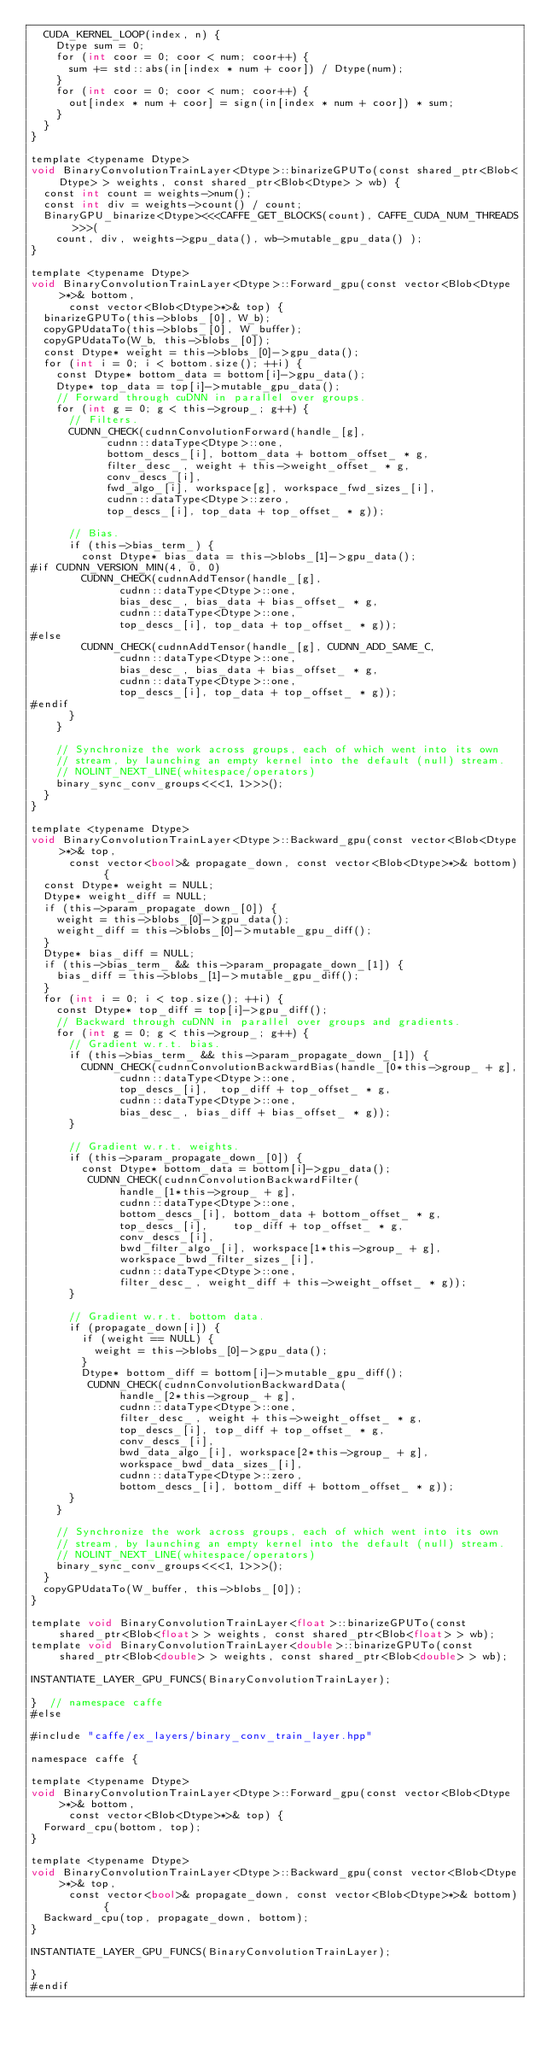Convert code to text. <code><loc_0><loc_0><loc_500><loc_500><_Cuda_>  CUDA_KERNEL_LOOP(index, n) {
    Dtype sum = 0;
    for (int coor = 0; coor < num; coor++) {
      sum += std::abs(in[index * num + coor]) / Dtype(num);
    }
    for (int coor = 0; coor < num; coor++) {
      out[index * num + coor] = sign(in[index * num + coor]) * sum;
    }
  }  
}

template <typename Dtype>
void BinaryConvolutionTrainLayer<Dtype>::binarizeGPUTo(const shared_ptr<Blob<Dtype> > weights, const shared_ptr<Blob<Dtype> > wb) {
  const int count = weights->num();
  const int div = weights->count() / count;
  BinaryGPU_binarize<Dtype><<<CAFFE_GET_BLOCKS(count), CAFFE_CUDA_NUM_THREADS>>>(
    count, div, weights->gpu_data(), wb->mutable_gpu_data() );
}

template <typename Dtype>
void BinaryConvolutionTrainLayer<Dtype>::Forward_gpu(const vector<Blob<Dtype>*>& bottom,
      const vector<Blob<Dtype>*>& top) {
  binarizeGPUTo(this->blobs_[0], W_b);
  copyGPUdataTo(this->blobs_[0], W_buffer);
  copyGPUdataTo(W_b, this->blobs_[0]);
  const Dtype* weight = this->blobs_[0]->gpu_data();
  for (int i = 0; i < bottom.size(); ++i) {
    const Dtype* bottom_data = bottom[i]->gpu_data();
    Dtype* top_data = top[i]->mutable_gpu_data();
    // Forward through cuDNN in parallel over groups.
    for (int g = 0; g < this->group_; g++) {
      // Filters.
      CUDNN_CHECK(cudnnConvolutionForward(handle_[g],
            cudnn::dataType<Dtype>::one,
            bottom_descs_[i], bottom_data + bottom_offset_ * g,
            filter_desc_, weight + this->weight_offset_ * g,
            conv_descs_[i],
            fwd_algo_[i], workspace[g], workspace_fwd_sizes_[i],
            cudnn::dataType<Dtype>::zero,
            top_descs_[i], top_data + top_offset_ * g));

      // Bias.
      if (this->bias_term_) {
        const Dtype* bias_data = this->blobs_[1]->gpu_data();
#if CUDNN_VERSION_MIN(4, 0, 0)
        CUDNN_CHECK(cudnnAddTensor(handle_[g],
              cudnn::dataType<Dtype>::one,
              bias_desc_, bias_data + bias_offset_ * g,
              cudnn::dataType<Dtype>::one,
              top_descs_[i], top_data + top_offset_ * g));
#else
        CUDNN_CHECK(cudnnAddTensor(handle_[g], CUDNN_ADD_SAME_C,
              cudnn::dataType<Dtype>::one,
              bias_desc_, bias_data + bias_offset_ * g,
              cudnn::dataType<Dtype>::one,
              top_descs_[i], top_data + top_offset_ * g));
#endif
      }
    }

    // Synchronize the work across groups, each of which went into its own
    // stream, by launching an empty kernel into the default (null) stream.
    // NOLINT_NEXT_LINE(whitespace/operators)
    binary_sync_conv_groups<<<1, 1>>>();
  }
}

template <typename Dtype>
void BinaryConvolutionTrainLayer<Dtype>::Backward_gpu(const vector<Blob<Dtype>*>& top,
      const vector<bool>& propagate_down, const vector<Blob<Dtype>*>& bottom) {
  const Dtype* weight = NULL;
  Dtype* weight_diff = NULL;
  if (this->param_propagate_down_[0]) {
    weight = this->blobs_[0]->gpu_data();
    weight_diff = this->blobs_[0]->mutable_gpu_diff();
  }
  Dtype* bias_diff = NULL;
  if (this->bias_term_ && this->param_propagate_down_[1]) {
    bias_diff = this->blobs_[1]->mutable_gpu_diff();
  }
  for (int i = 0; i < top.size(); ++i) {
    const Dtype* top_diff = top[i]->gpu_diff();
    // Backward through cuDNN in parallel over groups and gradients.
    for (int g = 0; g < this->group_; g++) {
      // Gradient w.r.t. bias.
      if (this->bias_term_ && this->param_propagate_down_[1]) {
        CUDNN_CHECK(cudnnConvolutionBackwardBias(handle_[0*this->group_ + g],
              cudnn::dataType<Dtype>::one,
              top_descs_[i],  top_diff + top_offset_ * g,
              cudnn::dataType<Dtype>::one,
              bias_desc_, bias_diff + bias_offset_ * g));
      }

      // Gradient w.r.t. weights.
      if (this->param_propagate_down_[0]) {
        const Dtype* bottom_data = bottom[i]->gpu_data();
         CUDNN_CHECK(cudnnConvolutionBackwardFilter(
              handle_[1*this->group_ + g],
              cudnn::dataType<Dtype>::one,
              bottom_descs_[i], bottom_data + bottom_offset_ * g,
              top_descs_[i],    top_diff + top_offset_ * g,
              conv_descs_[i],
              bwd_filter_algo_[i], workspace[1*this->group_ + g],
              workspace_bwd_filter_sizes_[i],
              cudnn::dataType<Dtype>::one,
              filter_desc_, weight_diff + this->weight_offset_ * g)); 
      }

      // Gradient w.r.t. bottom data.
      if (propagate_down[i]) {
        if (weight == NULL) {
          weight = this->blobs_[0]->gpu_data();
        }
        Dtype* bottom_diff = bottom[i]->mutable_gpu_diff();
         CUDNN_CHECK(cudnnConvolutionBackwardData(
              handle_[2*this->group_ + g],
              cudnn::dataType<Dtype>::one,
              filter_desc_, weight + this->weight_offset_ * g,
              top_descs_[i], top_diff + top_offset_ * g,
              conv_descs_[i],
              bwd_data_algo_[i], workspace[2*this->group_ + g],
              workspace_bwd_data_sizes_[i],
              cudnn::dataType<Dtype>::zero,
              bottom_descs_[i], bottom_diff + bottom_offset_ * g));
      }
    }

    // Synchronize the work across groups, each of which went into its own
    // stream, by launching an empty kernel into the default (null) stream.
    // NOLINT_NEXT_LINE(whitespace/operators)
    binary_sync_conv_groups<<<1, 1>>>();
  }
  copyGPUdataTo(W_buffer, this->blobs_[0]);
}

template void BinaryConvolutionTrainLayer<float>::binarizeGPUTo(const shared_ptr<Blob<float> > weights, const shared_ptr<Blob<float> > wb);
template void BinaryConvolutionTrainLayer<double>::binarizeGPUTo(const shared_ptr<Blob<double> > weights, const shared_ptr<Blob<double> > wb);

INSTANTIATE_LAYER_GPU_FUNCS(BinaryConvolutionTrainLayer);

}  // namespace caffe
#else

#include "caffe/ex_layers/binary_conv_train_layer.hpp"

namespace caffe {

template <typename Dtype>
void BinaryConvolutionTrainLayer<Dtype>::Forward_gpu(const vector<Blob<Dtype>*>& bottom,
      const vector<Blob<Dtype>*>& top) {
  Forward_cpu(bottom, top);
}

template <typename Dtype>
void BinaryConvolutionTrainLayer<Dtype>::Backward_gpu(const vector<Blob<Dtype>*>& top,
      const vector<bool>& propagate_down, const vector<Blob<Dtype>*>& bottom) {
  Backward_cpu(top, propagate_down, bottom);
}

INSTANTIATE_LAYER_GPU_FUNCS(BinaryConvolutionTrainLayer);

}
#endif
</code> 